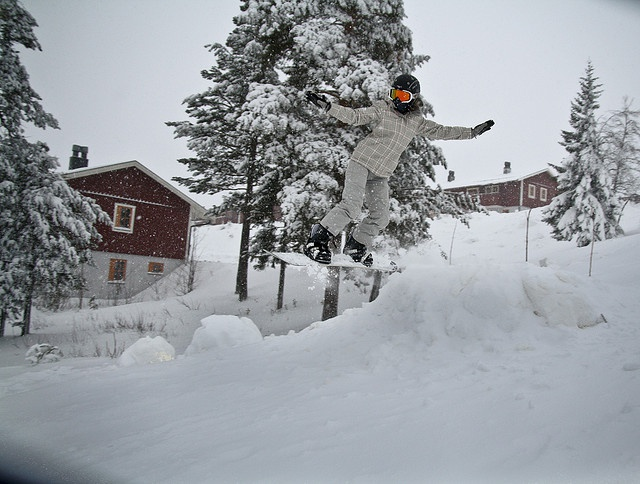Describe the objects in this image and their specific colors. I can see people in black, darkgray, and gray tones and snowboard in black, lightgray, darkgray, and gray tones in this image. 